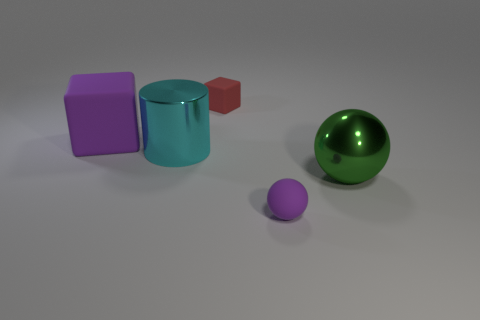Add 2 big blue metal blocks. How many objects exist? 7 Subtract all spheres. How many objects are left? 3 Add 2 metal objects. How many metal objects exist? 4 Subtract 0 yellow cylinders. How many objects are left? 5 Subtract all red rubber objects. Subtract all purple rubber balls. How many objects are left? 3 Add 4 large purple things. How many large purple things are left? 5 